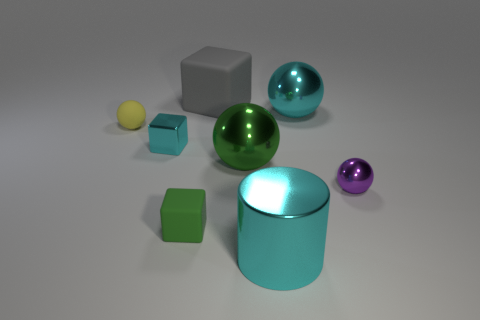Subtract 1 balls. How many balls are left? 3 Add 2 small blue cylinders. How many objects exist? 10 Subtract all cylinders. How many objects are left? 7 Subtract 0 purple cubes. How many objects are left? 8 Subtract all small green rubber spheres. Subtract all yellow rubber spheres. How many objects are left? 7 Add 6 cyan shiny cubes. How many cyan shiny cubes are left? 7 Add 7 big gray matte objects. How many big gray matte objects exist? 8 